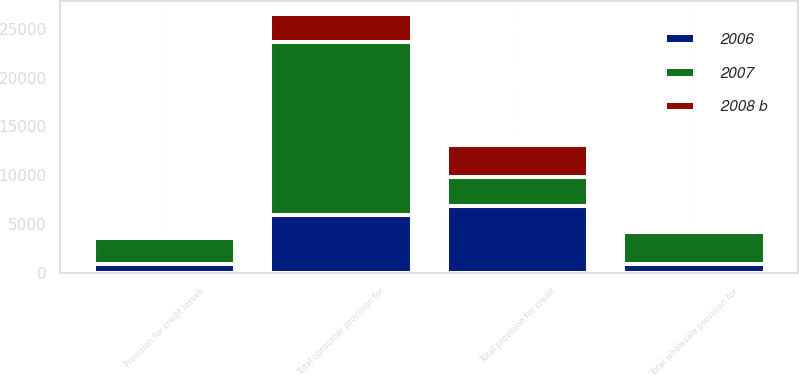<chart> <loc_0><loc_0><loc_500><loc_500><stacked_bar_chart><ecel><fcel>Provision for credit losses<fcel>Total wholesale provision for<fcel>Total consumer provision for<fcel>Total provision for credit<nl><fcel>2007<fcel>2681<fcel>3327<fcel>17652<fcel>2949<nl><fcel>2006<fcel>934<fcel>934<fcel>5930<fcel>6864<nl><fcel>2008 b<fcel>321<fcel>321<fcel>2949<fcel>3270<nl></chart> 